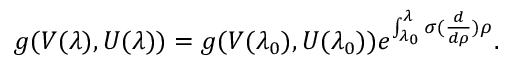<formula> <loc_0><loc_0><loc_500><loc_500>g ( V ( \lambda ) , U ( \lambda ) ) = g ( V ( \lambda _ { 0 } ) , U ( \lambda _ { 0 } ) ) e ^ { \int _ { \lambda _ { 0 } } ^ { \lambda } \sigma ( \frac { d } { d \rho } ) \rho } .</formula> 